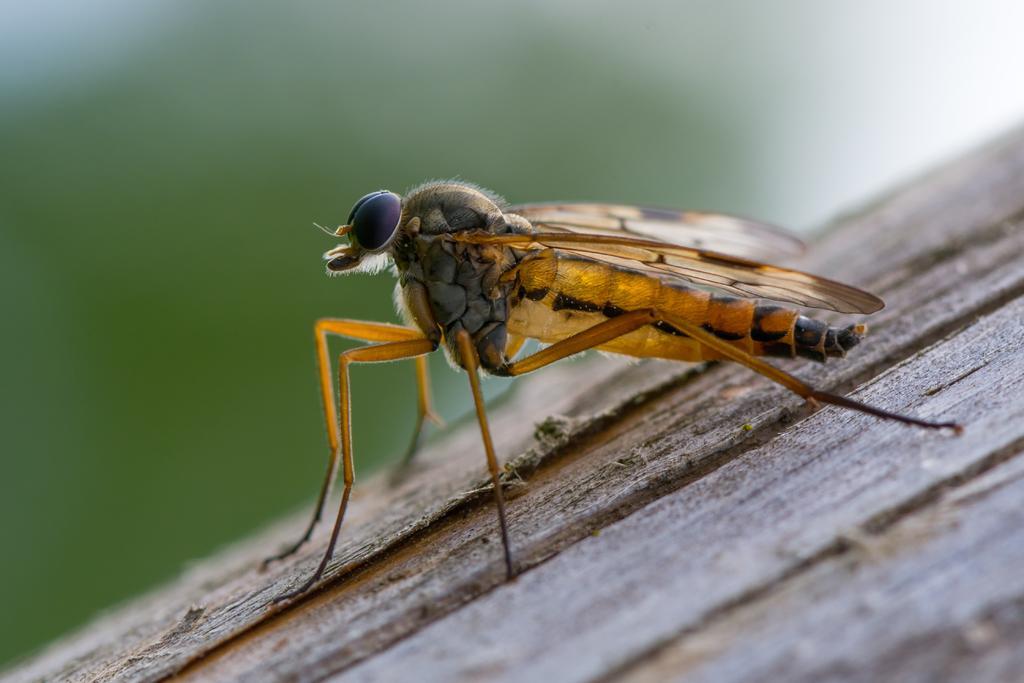Describe this image in one or two sentences. In this picture there is an insect in the center of the image. 